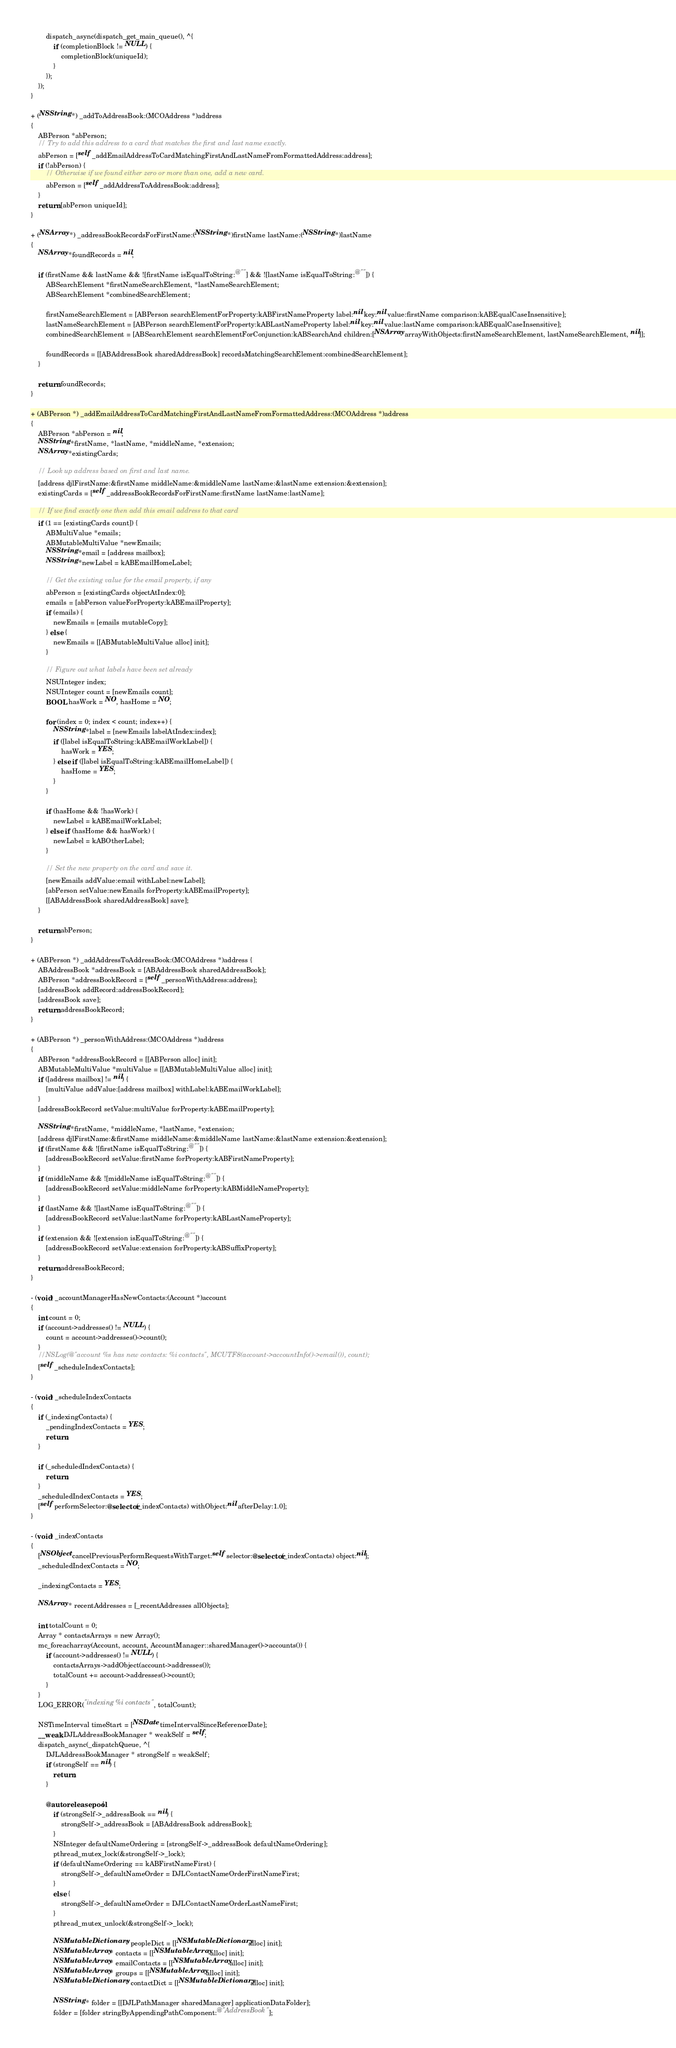Convert code to text. <code><loc_0><loc_0><loc_500><loc_500><_ObjectiveC_>        dispatch_async(dispatch_get_main_queue(), ^{
            if (completionBlock != NULL) {
                completionBlock(uniqueId);
            }
        });
    });
}

+ (NSString *) _addToAddressBook:(MCOAddress *)address
{
    ABPerson *abPerson;
    // Try to add this address to a card that matches the first and last name exactly.
    abPerson = [self _addEmailAddressToCardMatchingFirstAndLastNameFromFormattedAddress:address];
    if (!abPerson) {
        // Otherwise if we found either zero or more than one, add a new card.
        abPerson = [self _addAddressToAddressBook:address];
    }
    return [abPerson uniqueId];
}

+ (NSArray *) _addressBookRecordsForFirstName:(NSString *)firstName lastName:(NSString *)lastName
{
    NSArray *foundRecords = nil;

    if (firstName && lastName && ![firstName isEqualToString:@""] && ![lastName isEqualToString:@""]) {
        ABSearchElement *firstNameSearchElement, *lastNameSearchElement;
        ABSearchElement *combinedSearchElement;

        firstNameSearchElement = [ABPerson searchElementForProperty:kABFirstNameProperty label:nil key:nil value:firstName comparison:kABEqualCaseInsensitive];
        lastNameSearchElement = [ABPerson searchElementForProperty:kABLastNameProperty label:nil key:nil value:lastName comparison:kABEqualCaseInsensitive];
        combinedSearchElement = [ABSearchElement searchElementForConjunction:kABSearchAnd children:[NSArray arrayWithObjects:firstNameSearchElement, lastNameSearchElement, nil]];

        foundRecords = [[ABAddressBook sharedAddressBook] recordsMatchingSearchElement:combinedSearchElement];
    }

    return foundRecords;
}

+ (ABPerson *) _addEmailAddressToCardMatchingFirstAndLastNameFromFormattedAddress:(MCOAddress *)address
{
    ABPerson *abPerson = nil;
    NSString *firstName, *lastName, *middleName, *extension;
    NSArray *existingCards;

    // Look up address based on first and last name.
    [address djlFirstName:&firstName middleName:&middleName lastName:&lastName extension:&extension];
    existingCards = [self _addressBookRecordsForFirstName:firstName lastName:lastName];

    // If we find exactly one then add this email address to that card
    if (1 == [existingCards count]) {
        ABMultiValue *emails;
        ABMutableMultiValue *newEmails;
        NSString *email = [address mailbox];
        NSString *newLabel = kABEmailHomeLabel;

        // Get the existing value for the email property, if any
        abPerson = [existingCards objectAtIndex:0];
        emails = [abPerson valueForProperty:kABEmailProperty];
        if (emails) {
            newEmails = [emails mutableCopy];
        } else {
            newEmails = [[ABMutableMultiValue alloc] init];
        }

        // Figure out what labels have been set already
        NSUInteger index;
        NSUInteger count = [newEmails count];
        BOOL hasWork = NO, hasHome = NO;

        for (index = 0; index < count; index++) {
            NSString *label = [newEmails labelAtIndex:index];
            if ([label isEqualToString:kABEmailWorkLabel]) {
                hasWork = YES;
            } else if ([label isEqualToString:kABEmailHomeLabel]) {
                hasHome = YES;
            }
        }

        if (hasHome && !hasWork) {
            newLabel = kABEmailWorkLabel;
        } else if (hasHome && hasWork) {
            newLabel = kABOtherLabel;
        }

        // Set the new property on the card and save it.
        [newEmails addValue:email withLabel:newLabel];
        [abPerson setValue:newEmails forProperty:kABEmailProperty];
        [[ABAddressBook sharedAddressBook] save];
    }

    return abPerson;
}

+ (ABPerson *) _addAddressToAddressBook:(MCOAddress *)address {
    ABAddressBook *addressBook = [ABAddressBook sharedAddressBook];
    ABPerson *addressBookRecord = [self _personWithAddress:address];
    [addressBook addRecord:addressBookRecord];
    [addressBook save];
    return addressBookRecord;
}

+ (ABPerson *) _personWithAddress:(MCOAddress *)address
{
    ABPerson *addressBookRecord = [[ABPerson alloc] init];
    ABMutableMultiValue *multiValue = [[ABMutableMultiValue alloc] init];
    if ([address mailbox] != nil) {
        [multiValue addValue:[address mailbox] withLabel:kABEmailWorkLabel];
    }
    [addressBookRecord setValue:multiValue forProperty:kABEmailProperty];

    NSString *firstName, *middleName, *lastName, *extension;
    [address djlFirstName:&firstName middleName:&middleName lastName:&lastName extension:&extension];
    if (firstName && ![firstName isEqualToString:@""]) {
        [addressBookRecord setValue:firstName forProperty:kABFirstNameProperty];
    }
    if (middleName && ![middleName isEqualToString:@""]) {
        [addressBookRecord setValue:middleName forProperty:kABMiddleNameProperty];
    }
    if (lastName && ![lastName isEqualToString:@""]) {
        [addressBookRecord setValue:lastName forProperty:kABLastNameProperty];
    }
    if (extension && ![extension isEqualToString:@""]) {
        [addressBookRecord setValue:extension forProperty:kABSuffixProperty];
    }
    return addressBookRecord;
}

- (void) _accountManagerHasNewContacts:(Account *)account
{
    int count = 0;
    if (account->addresses() != NULL) {
        count = account->addresses()->count();
    }
    //NSLog(@"account %s has new contacts: %i contacts", MCUTF8(account->accountInfo()->email()), count);
    [self _scheduleIndexContacts];
}

- (void) _scheduleIndexContacts
{
    if (_indexingContacts) {
        _pendingIndexContacts = YES;
        return;
    }

    if (_scheduledIndexContacts) {
        return;
    }
    _scheduledIndexContacts = YES;
    [self performSelector:@selector(_indexContacts) withObject:nil afterDelay:1.0];
}

- (void) _indexContacts
{
    [NSObject cancelPreviousPerformRequestsWithTarget:self selector:@selector(_indexContacts) object:nil];
    _scheduledIndexContacts = NO;

    _indexingContacts = YES;

    NSArray * recentAddresses = [_recentAddresses allObjects];

    int totalCount = 0;
    Array * contactsArrays = new Array();
    mc_foreacharray(Account, account, AccountManager::sharedManager()->accounts()) {
        if (account->addresses() != NULL) {
            contactsArrays->addObject(account->addresses());
            totalCount += account->addresses()->count();
        }
    }
    LOG_ERROR("indexing %i contacts", totalCount);

    NSTimeInterval timeStart = [NSDate timeIntervalSinceReferenceDate];
    __weak DJLAddressBookManager * weakSelf = self;
    dispatch_async(_dispatchQueue, ^{
        DJLAddressBookManager * strongSelf = weakSelf;
        if (strongSelf == nil) {
            return;
        }

        @autoreleasepool {
            if (strongSelf->_addressBook == nil) {
                strongSelf->_addressBook = [ABAddressBook addressBook];
            }
            NSInteger defaultNameOrdering = [strongSelf->_addressBook defaultNameOrdering];
            pthread_mutex_lock(&strongSelf->_lock);
            if (defaultNameOrdering == kABFirstNameFirst) {
                strongSelf->_defaultNameOrder = DJLContactNameOrderFirstNameFirst;
            }
            else {
                strongSelf->_defaultNameOrder = DJLContactNameOrderLastNameFirst;
            }
            pthread_mutex_unlock(&strongSelf->_lock);

            NSMutableDictionary * peopleDict = [[NSMutableDictionary alloc] init];
            NSMutableArray * contacts = [[NSMutableArray alloc] init];
            NSMutableArray * emailContacts = [[NSMutableArray alloc] init];
            NSMutableArray * groups = [[NSMutableArray alloc] init];
            NSMutableDictionary * contactDict = [[NSMutableDictionary alloc] init];

            NSString * folder = [[DJLPathManager sharedManager] applicationDataFolder];
            folder = [folder stringByAppendingPathComponent:@"AddressBook"];</code> 